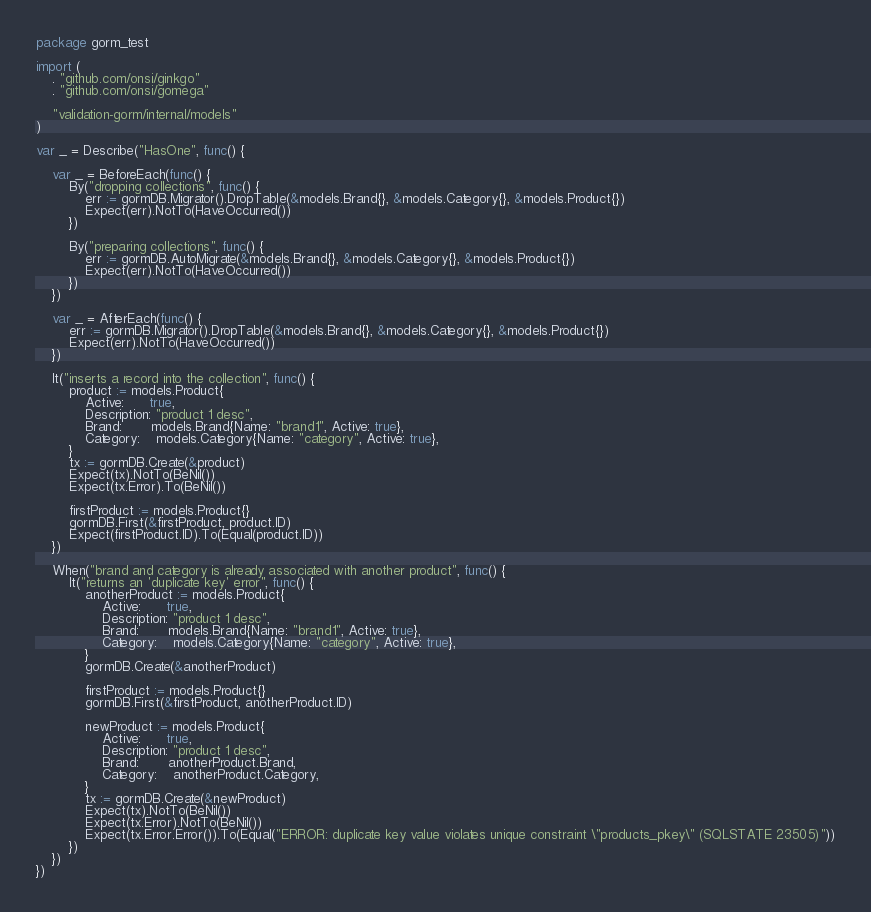<code> <loc_0><loc_0><loc_500><loc_500><_Go_>package gorm_test

import (
	. "github.com/onsi/ginkgo"
	. "github.com/onsi/gomega"

	"validation-gorm/internal/models"
)

var _ = Describe("HasOne", func() {

	var _ = BeforeEach(func() {
		By("dropping collections", func() {
			err := gormDB.Migrator().DropTable(&models.Brand{}, &models.Category{}, &models.Product{})
			Expect(err).NotTo(HaveOccurred())
		})

		By("preparing collections", func() {
			err := gormDB.AutoMigrate(&models.Brand{}, &models.Category{}, &models.Product{})
			Expect(err).NotTo(HaveOccurred())
		})
	})

	var _ = AfterEach(func() {
		err := gormDB.Migrator().DropTable(&models.Brand{}, &models.Category{}, &models.Product{})
		Expect(err).NotTo(HaveOccurred())
	})

	It("inserts a record into the collection", func() {
		product := models.Product{
			Active:      true,
			Description: "product 1 desc",
			Brand:       models.Brand{Name: "brand1", Active: true},
			Category:    models.Category{Name: "category", Active: true},
		}
		tx := gormDB.Create(&product)
		Expect(tx).NotTo(BeNil())
		Expect(tx.Error).To(BeNil())

		firstProduct := models.Product{}
		gormDB.First(&firstProduct, product.ID)
		Expect(firstProduct.ID).To(Equal(product.ID))
	})

	When("brand and category is already associated with another product", func() {
		It("returns an 'duplicate key' error", func() {
			anotherProduct := models.Product{
				Active:      true,
				Description: "product 1 desc",
				Brand:       models.Brand{Name: "brand1", Active: true},
				Category:    models.Category{Name: "category", Active: true},
			}
			gormDB.Create(&anotherProduct)

			firstProduct := models.Product{}
			gormDB.First(&firstProduct, anotherProduct.ID)

			newProduct := models.Product{
				Active:      true,
				Description: "product 1 desc",
				Brand:       anotherProduct.Brand,
				Category:    anotherProduct.Category,
			}
			tx := gormDB.Create(&newProduct)
			Expect(tx).NotTo(BeNil())
			Expect(tx.Error).NotTo(BeNil())
			Expect(tx.Error.Error()).To(Equal("ERROR: duplicate key value violates unique constraint \"products_pkey\" (SQLSTATE 23505)"))
		})
	})
})
</code> 